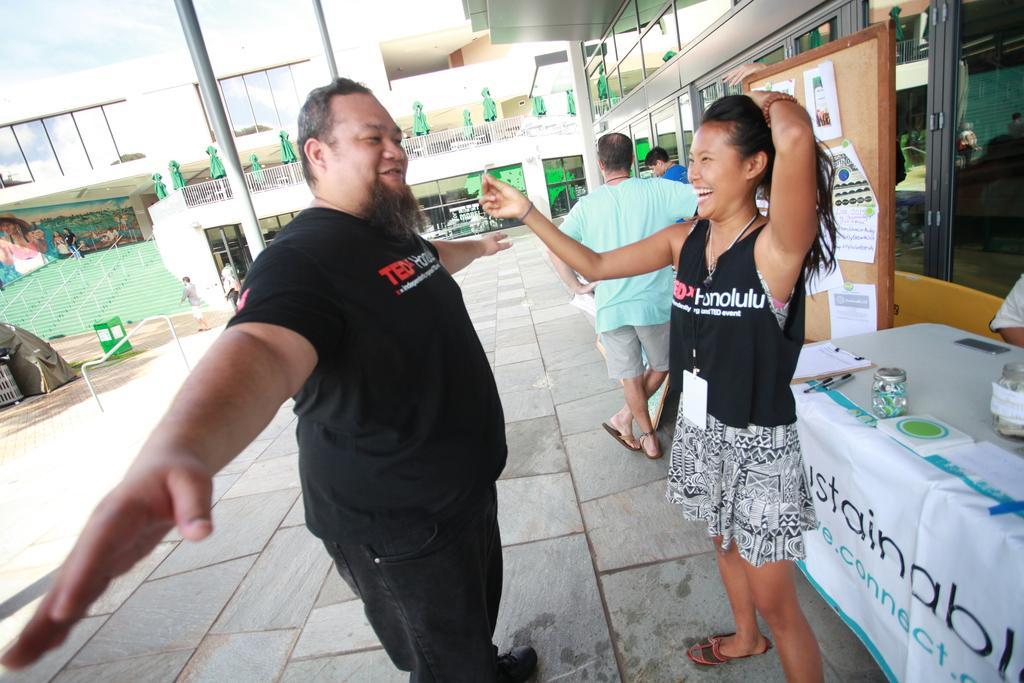Please provide a concise description of this image. In this picture there are people and we can see jars, clipboard, papers, pens and banner on the table. We can see glass windows, poles and posts attached to a board. In the background of the image we can see building, people, tent, railings, steps and objects. 